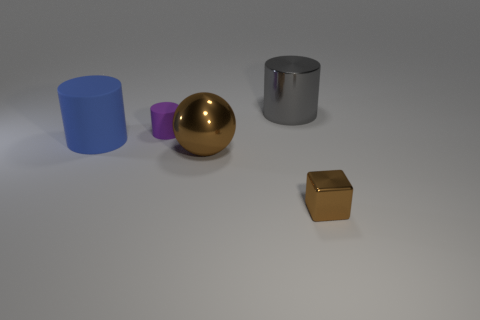Subtract all rubber cylinders. How many cylinders are left? 1 Add 3 tiny shiny cubes. How many objects exist? 8 Subtract all gray cylinders. How many cylinders are left? 2 Add 3 small green spheres. How many small green spheres exist? 3 Subtract 0 yellow spheres. How many objects are left? 5 Subtract all cubes. How many objects are left? 4 Subtract 2 cylinders. How many cylinders are left? 1 Subtract all yellow cylinders. Subtract all green spheres. How many cylinders are left? 3 Subtract all large metal cylinders. Subtract all large cylinders. How many objects are left? 2 Add 3 tiny metallic objects. How many tiny metallic objects are left? 4 